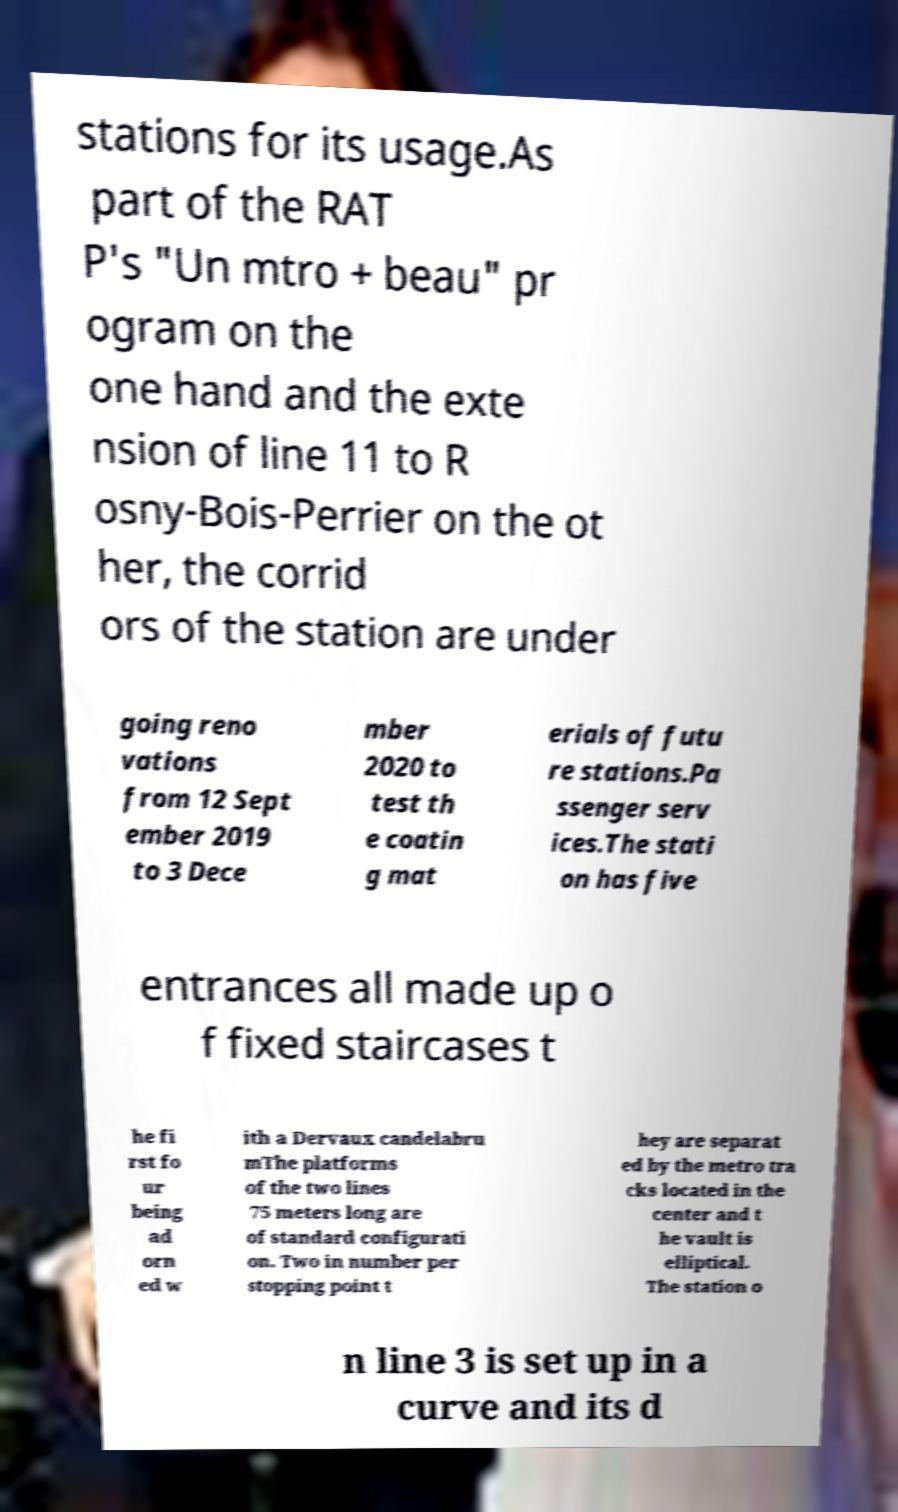What messages or text are displayed in this image? I need them in a readable, typed format. stations for its usage.As part of the RAT P's "Un mtro + beau" pr ogram on the one hand and the exte nsion of line 11 to R osny-Bois-Perrier on the ot her, the corrid ors of the station are under going reno vations from 12 Sept ember 2019 to 3 Dece mber 2020 to test th e coatin g mat erials of futu re stations.Pa ssenger serv ices.The stati on has five entrances all made up o f fixed staircases t he fi rst fo ur being ad orn ed w ith a Dervaux candelabru mThe platforms of the two lines 75 meters long are of standard configurati on. Two in number per stopping point t hey are separat ed by the metro tra cks located in the center and t he vault is elliptical. The station o n line 3 is set up in a curve and its d 